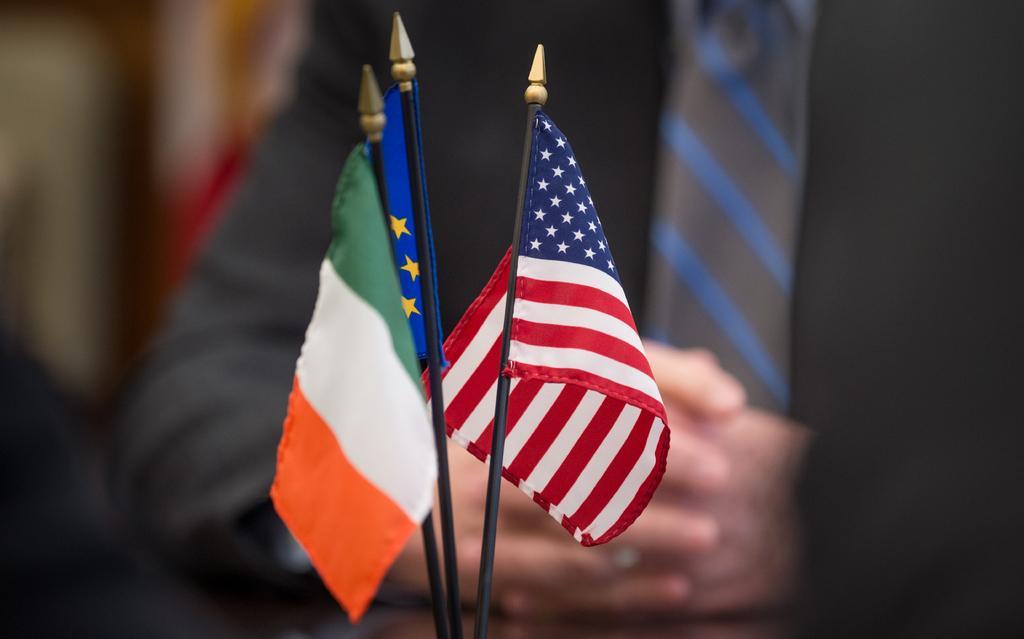Describe this image in one or two sentences. In the foreground of the image we can see some flags. In the background, we can see a person wearing a coat and tie. 